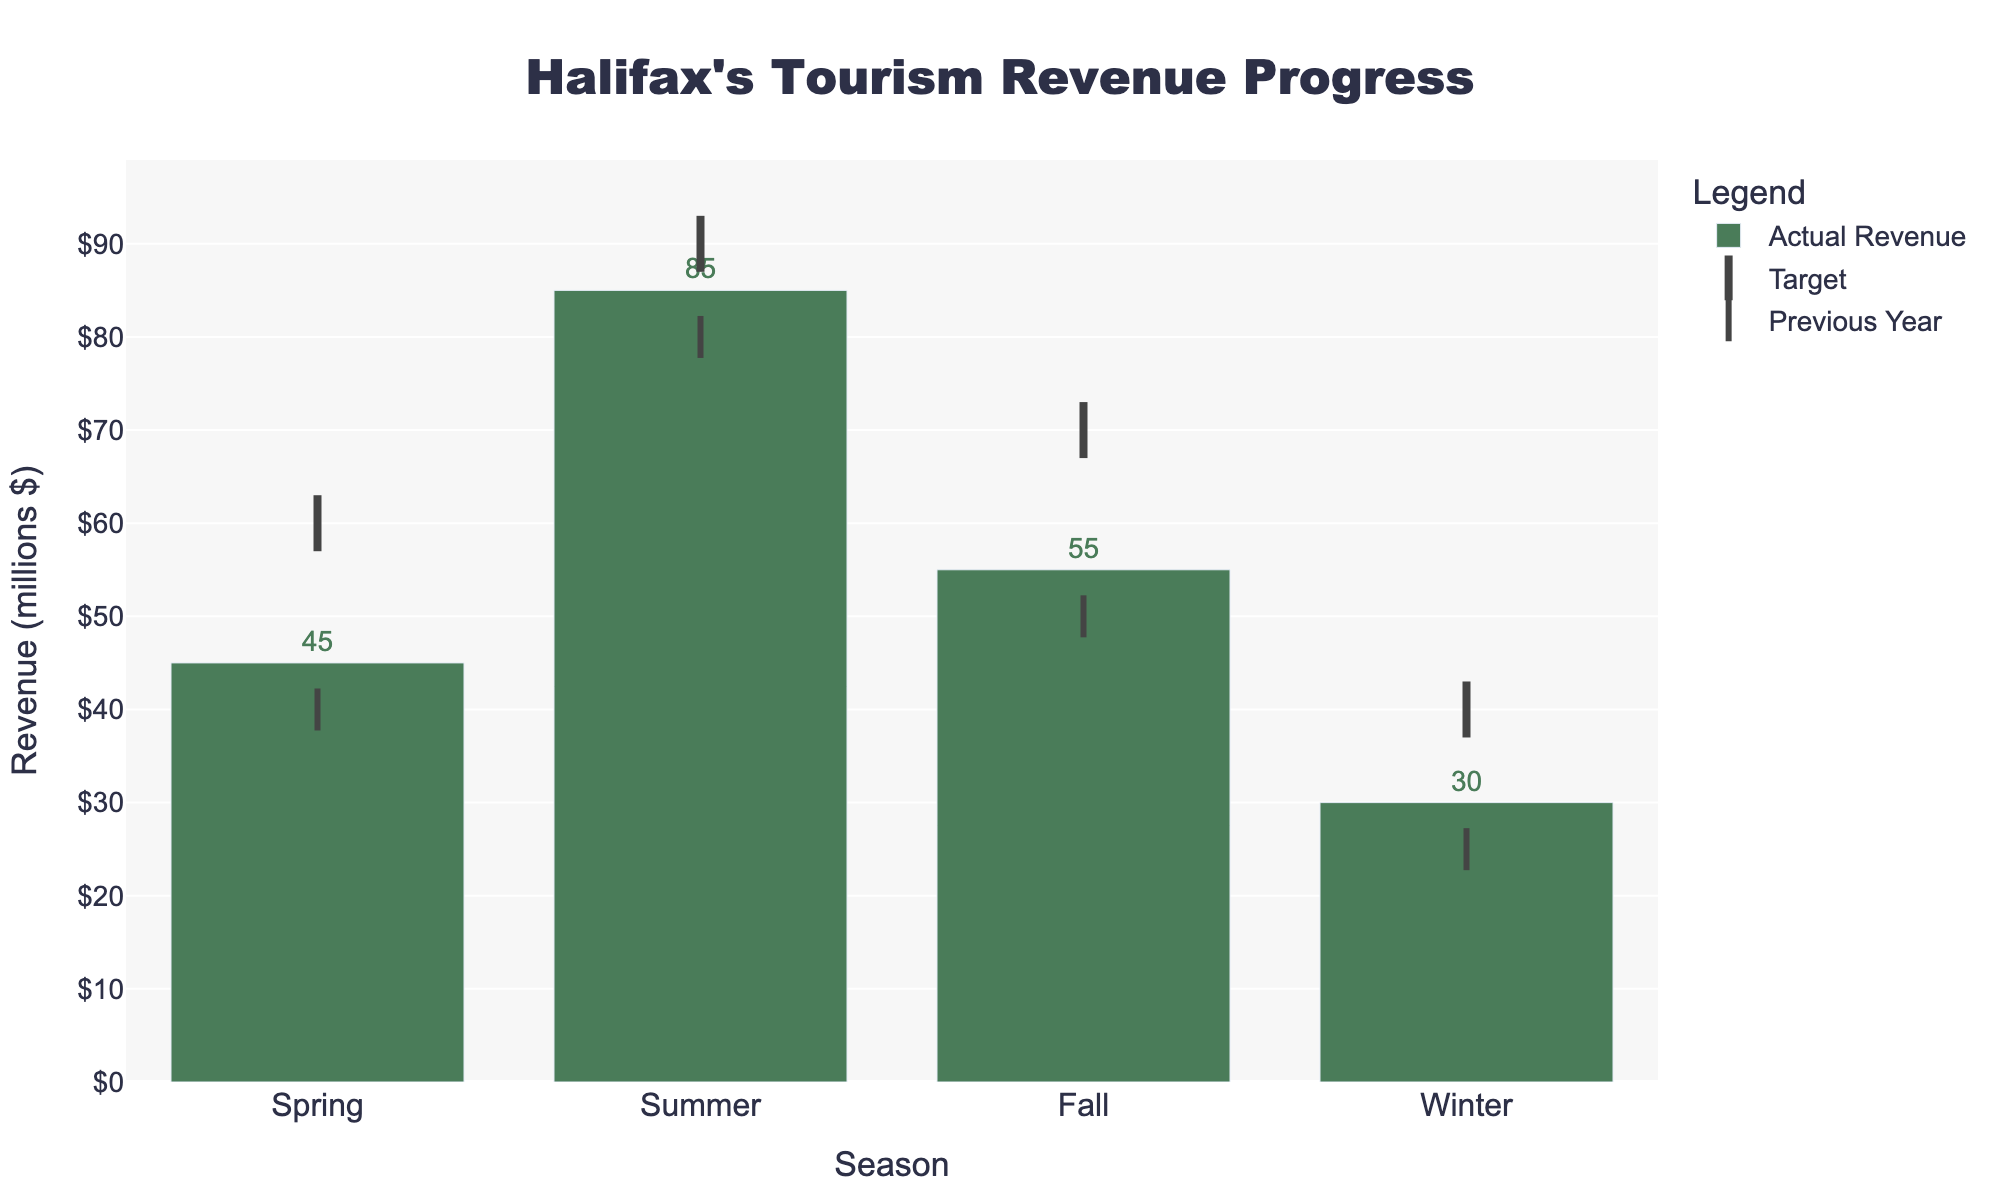How many seasons are displayed in the figure? Look at the x-axis which lists all the seasons represented in the figure. We see four seasons: Spring, Summer, Fall, and Winter.
Answer: 4 What is the target revenue for Summer? Look at the marker labeled "Target" for Summer, indicated by a line symbol pointing up and down. The marker for Summer is positioned at 90.
Answer: 90 million dollars How much more revenue was generated in Winter compared to the previous year? Compare the 'Actual Revenue' bar for Winter with the 'Previous Year' marker. Actual Revenue is 30 million and Previous Year is 25 million. 30 - 25 = 5
Answer: 5 million dollars Did any season's actual revenue surpass the target? Compare the 'Actual Revenue' bars with the 'Target' markers for all seasons. No season's actual revenue exceeded its target value.
Answer: No What's the difference between the target and the actual revenue for Fall? Subtract the 'Actual Revenue' for Fall from the 'Target' for Fall. Target is 70 million, and Actual Revenue is 55 million. 70 - 55 = 15
Answer: 15 million dollars Which season had the highest actual revenue? Look at the height of the 'Actual Revenue' bars for all seasons. Summer has the highest bar at 85 million.
Answer: Summer How did Spring's actual revenue compare to the previous year's performance? Compare the 'Actual Revenue' bar and the 'Previous Year' marker for Spring. Actual revenue is 45 million, and previous year is 40 million. 45 - 40 = 5
Answer: 5 million dollars higher What is the sum of the actual revenues across all seasons? Add the 'Actual Revenue' values for all seasons. 45 (Spring) + 85 (Summer) + 55 (Fall) + 30 (Winter) = 215
Answer: 215 million dollars Which season shows the smallest progression from the previous year's revenue? Calculate the difference between 'Actual Revenue' and 'Previous Year' for each season. Spring: 5 million, Summer: 5 million, Fall: 5 million, Winter: 5 million. They're all equal in this case.
Answer: They all show the same progression of 5 million dollars What's the average target revenue across all seasons? Calculate the sum of the target revenues and then divide by the number of seasons. 60 (Spring) + 90 (Summer) + 70 (Fall) + 40 (Winter) = 260. Average = 260 / 4 = 65
Answer: 65 million dollars 